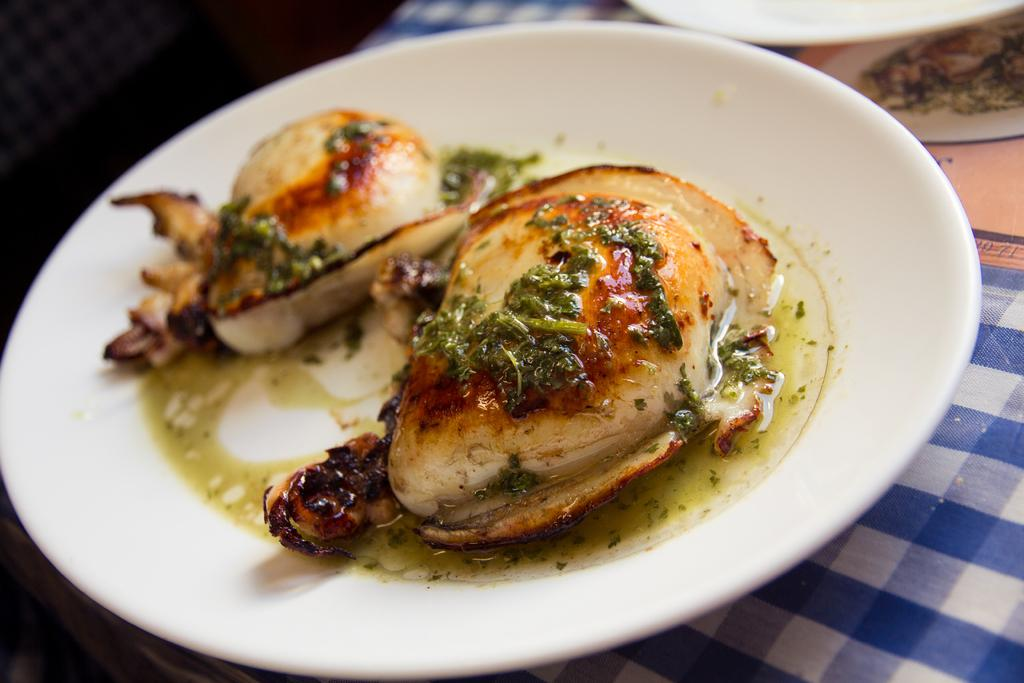How many plates are visible in the image? There are two plates in the image. What is the surface on which the plates are placed? The plates are on a cloth. Is there any food item present on the plates? Yes, there is a food item placed on one or both of the plates. How does the mark on the plate increase in size over time? There is no mark on the plate mentioned in the facts, so it cannot be determined if it increases in size over time. 